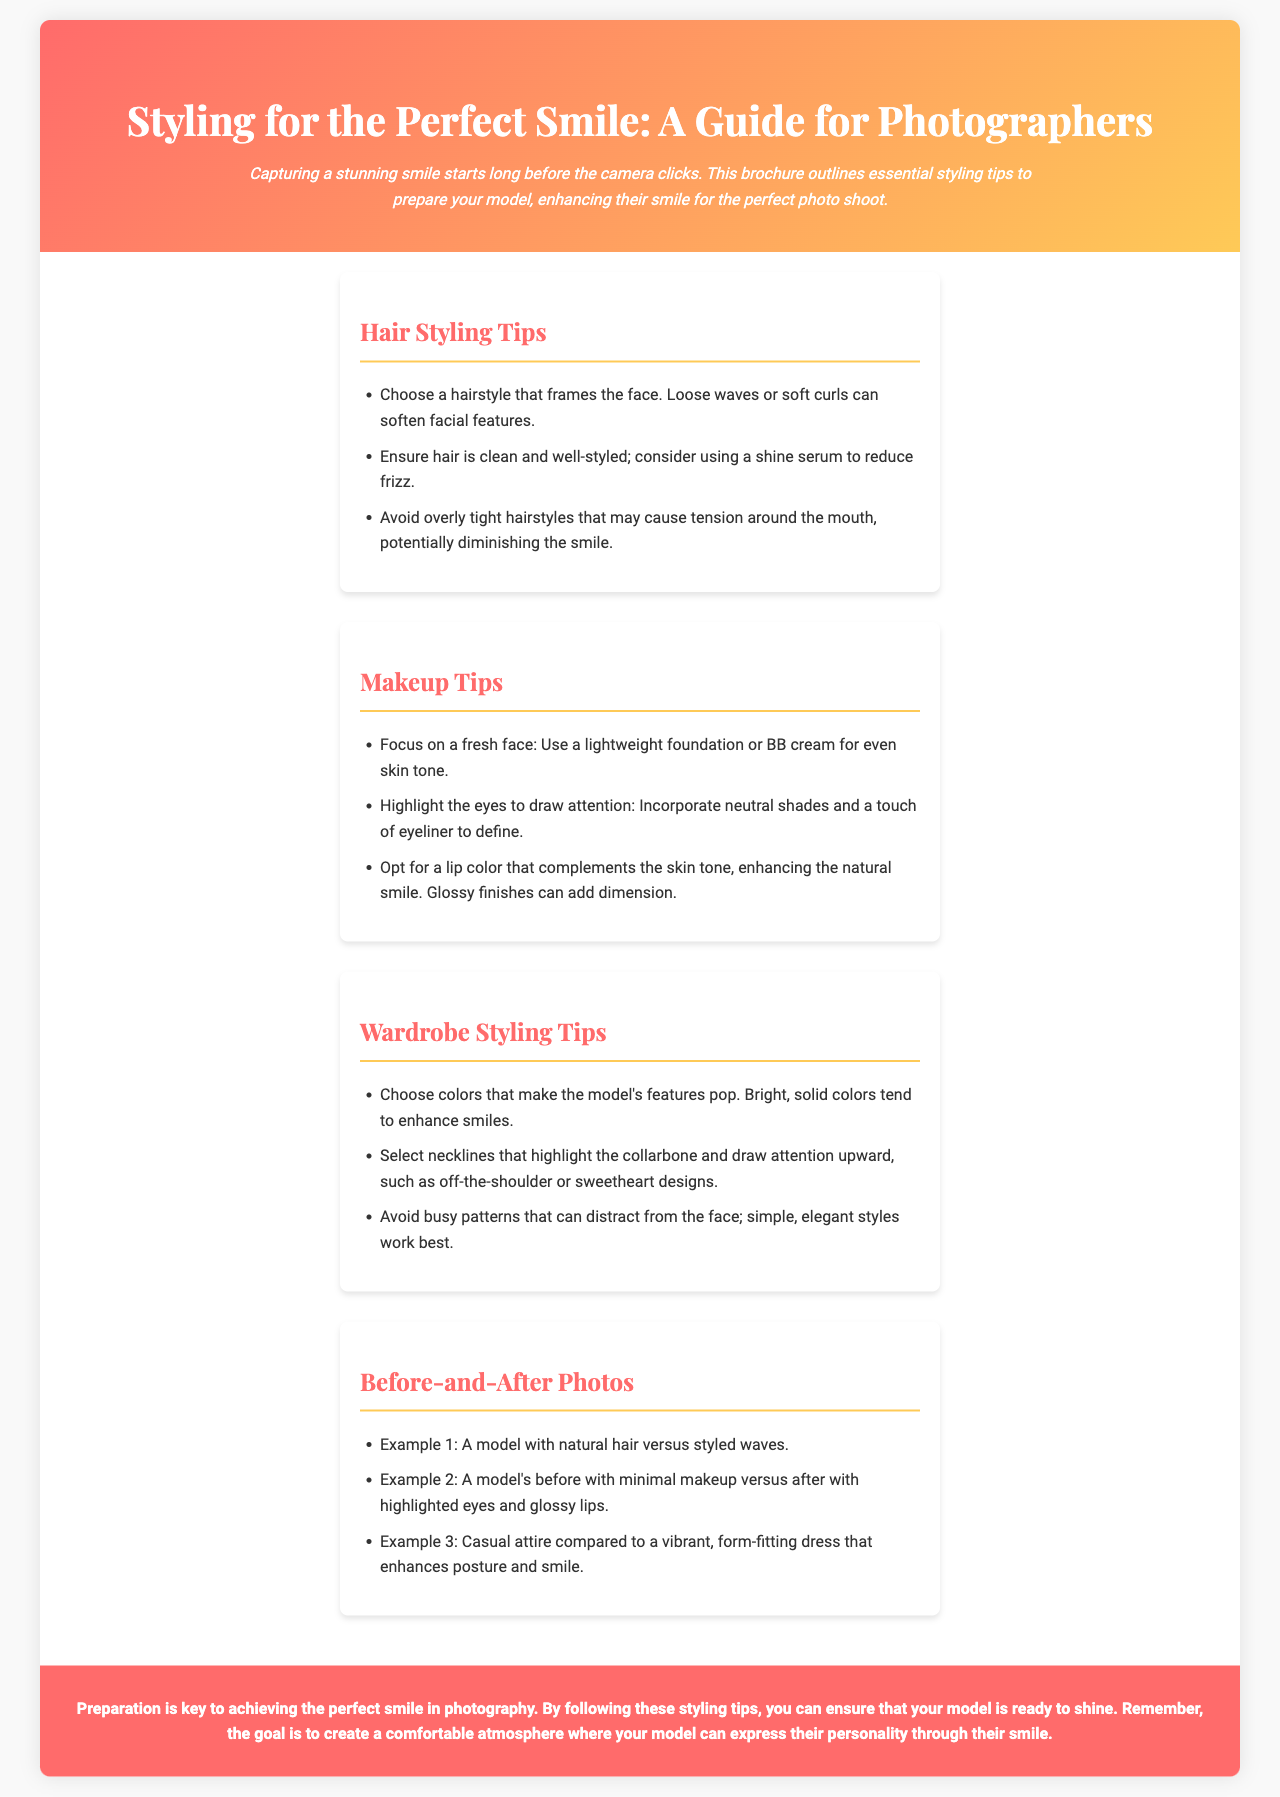What is the main purpose of the brochure? The brochure outlines essential styling tips to prepare your model, enhancing their smile for the perfect photo shoot.
Answer: To enhance smiles for photo shoots What color combination is used in the header? The header has a background gradient that transitions between the colors #ff6b6b and #feca57.
Answer: Red and yellow What hairstyle is recommended to enhance smiles? Loose waves or soft curls are suggested to soften facial features.
Answer: Loose waves What is a suggested makeup product for even skin tone? A lightweight foundation or BB cream is recommended for achieving an even skin tone.
Answer: BB cream Which type of necklines should be avoided? Busy patterns can distract from the face, so they should be avoided.
Answer: Busy patterns What is given as an example of a before-and-after transformation? A model's before with minimal makeup versus after with highlighted eyes and glossy lips is highlighted.
Answer: Minimal makeup versus highlighted eyes How does the brochure suggest to draw attention to the eyes? Incorporate neutral shades and a touch of eyeliner to define the eyes.
Answer: Neutral shades What is recommended to reduce frizz in hair styling? Using a shine serum is suggested to reduce frizz in hair.
Answer: Shine serum 